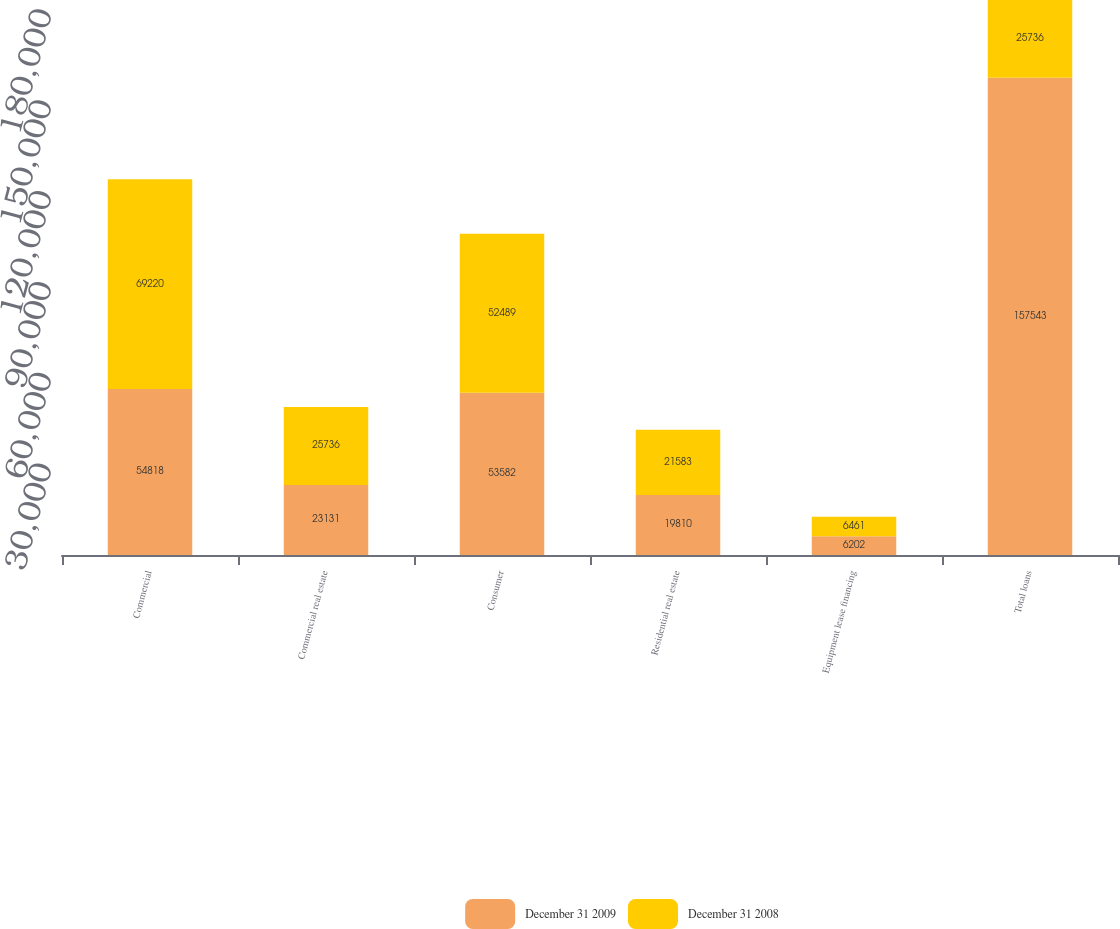<chart> <loc_0><loc_0><loc_500><loc_500><stacked_bar_chart><ecel><fcel>Commercial<fcel>Commercial real estate<fcel>Consumer<fcel>Residential real estate<fcel>Equipment lease financing<fcel>Total loans<nl><fcel>December 31 2009<fcel>54818<fcel>23131<fcel>53582<fcel>19810<fcel>6202<fcel>157543<nl><fcel>December 31 2008<fcel>69220<fcel>25736<fcel>52489<fcel>21583<fcel>6461<fcel>25736<nl></chart> 